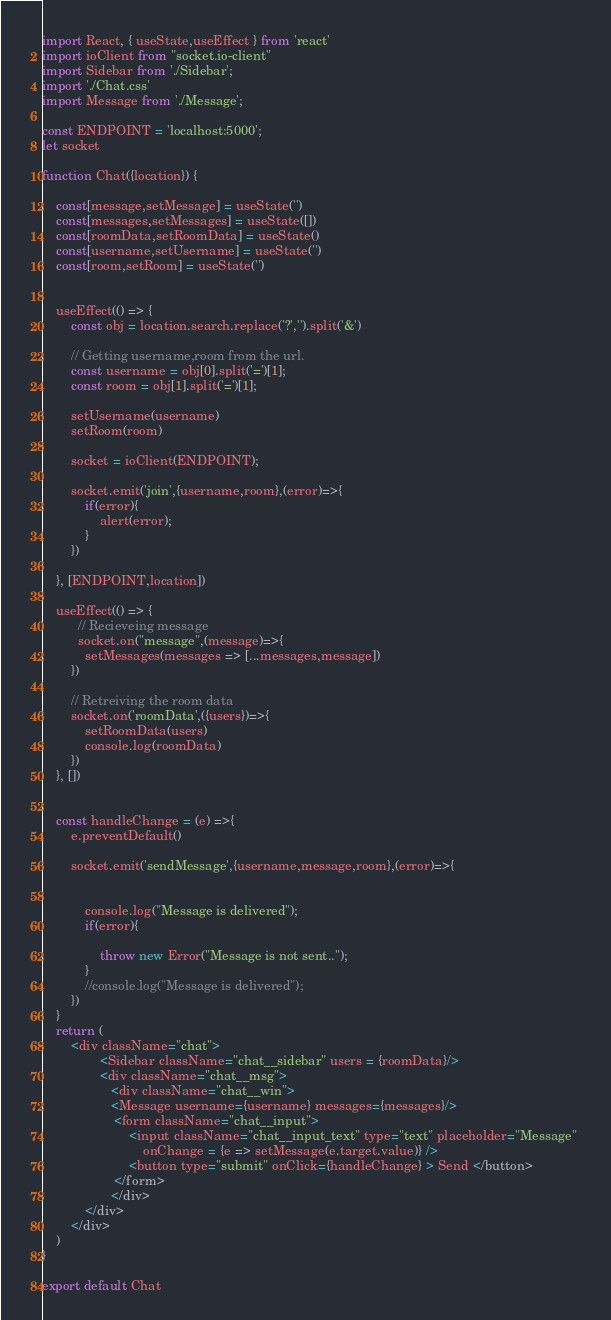Convert code to text. <code><loc_0><loc_0><loc_500><loc_500><_JavaScript_>import React, { useState,useEffect } from 'react'
import ioClient from "socket.io-client"
import Sidebar from './Sidebar';
import './Chat.css'
import Message from './Message';

const ENDPOINT = 'localhost:5000';
let socket

function Chat({location}) {

    const[message,setMessage] = useState('')
    const[messages,setMessages] = useState([])
    const[roomData,setRoomData] = useState()
    const[username,setUsername] = useState('')
    const[room,setRoom] = useState('')


    useEffect(() => {
        const obj = location.search.replace('?','').split('&')

        // Getting username,room from the url.
        const username = obj[0].split('=')[1];
        const room = obj[1].split('=')[1];

        setUsername(username)
        setRoom(room)

        socket = ioClient(ENDPOINT);

        socket.emit('join',{username,room},(error)=>{
            if(error){
                alert(error);
            }
        })

    }, [ENDPOINT,location])
    
    useEffect(() => {
          // Recieveing message
          socket.on("message",(message)=>{
            setMessages(messages => [...messages,message])
        })

        // Retreiving the room data
        socket.on('roomData',({users})=>{
            setRoomData(users)
            console.log(roomData)
        })
    }, [])


    const handleChange = (e) =>{
        e.preventDefault()
        
        socket.emit('sendMessage',{username,message,room},(error)=>{


            console.log("Message is delivered");
            if(error){
                
                throw new Error("Message is not sent..");
            }
            //console.log("Message is delivered");
        })
    }
    return (
        <div className="chat">
                <Sidebar className="chat__sidebar" users = {roomData}/>
                <div className="chat__msg">
                   <div className="chat__win">
                   <Message username={username} messages={messages}/>
                    <form className="chat__input">
                        <input className="chat__input_text" type="text" placeholder="Message" 
                            onChange = {e => setMessage(e.target.value)} />
                        <button type="submit" onClick={handleChange} > Send </button>
                    </form>
                   </div>
            </div>
        </div>
    )
}

export default Chat
</code> 